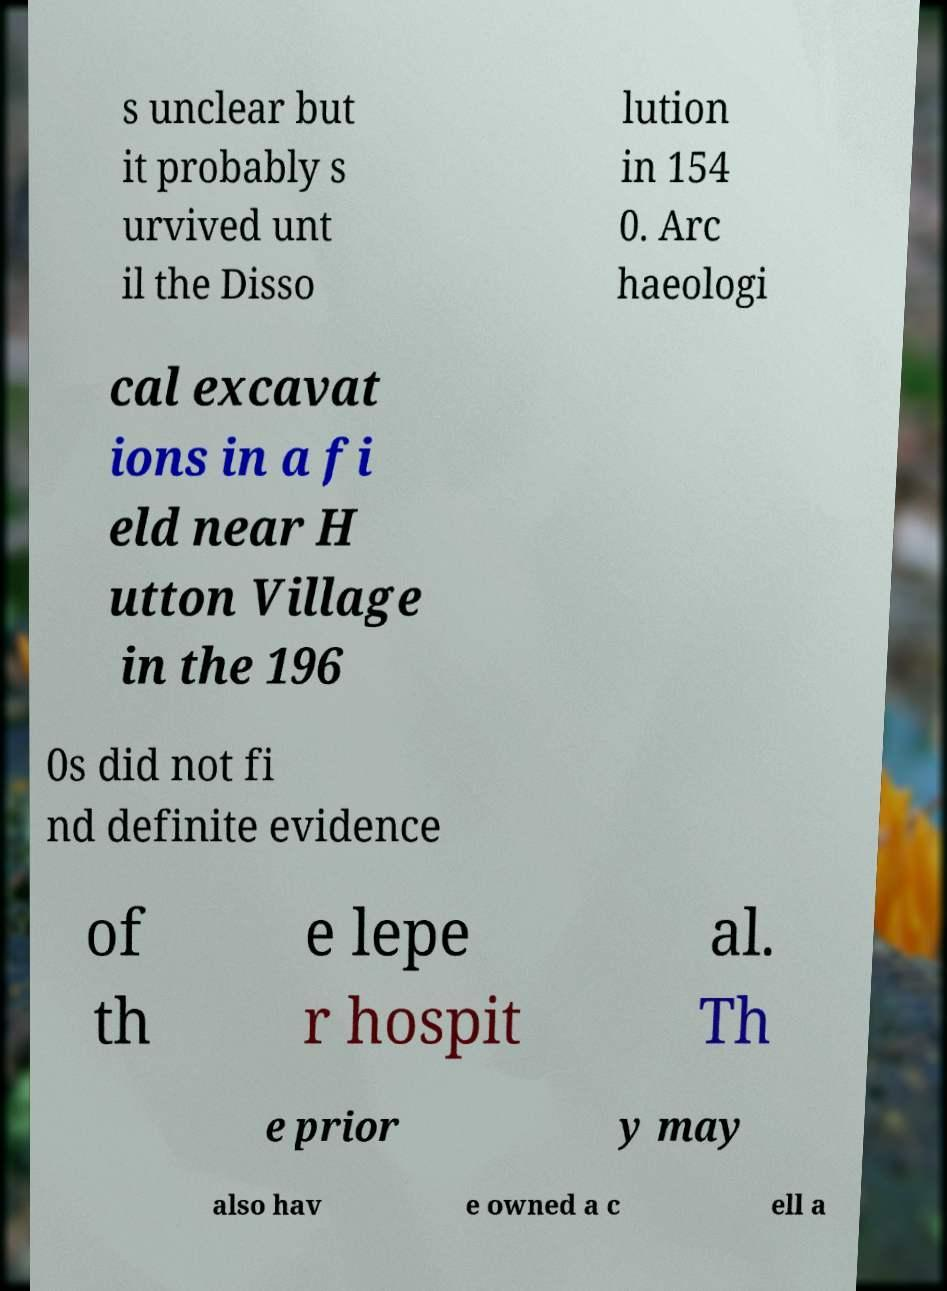Please read and relay the text visible in this image. What does it say? s unclear but it probably s urvived unt il the Disso lution in 154 0. Arc haeologi cal excavat ions in a fi eld near H utton Village in the 196 0s did not fi nd definite evidence of th e lepe r hospit al. Th e prior y may also hav e owned a c ell a 